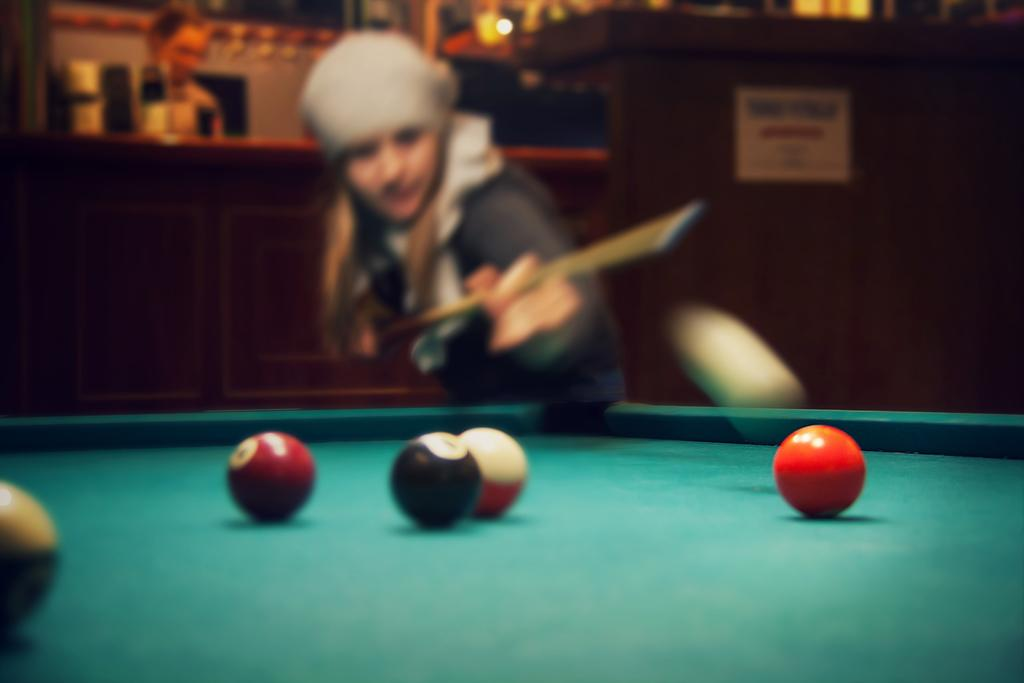Who is the main subject in the image? There is a woman in the image. What is the woman doing in the image? The woman is playing snookers. What object is the woman holding in her hands? The woman is holding a stick in her hands. What is the primary object on which the game is being played? There is a snooker board in the image. What are the small round objects on the snooker board? There are balls on the snooker board. Can you describe the person in the background of the image? There is a person standing in the background of the image. What type of boat can be seen in the image? There is no boat present in the image. How many pizzas are being served on the snooker board? There are no pizzas present in the image; it features a snooker board with balls. What school subject is being taught in the image? There is no indication of any school subject being taught in the image. 